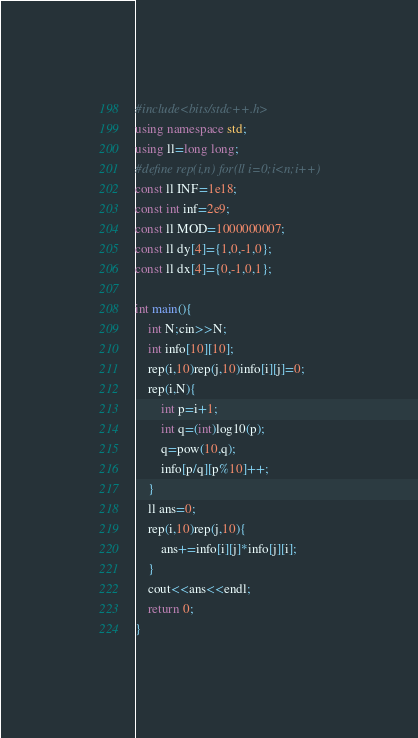<code> <loc_0><loc_0><loc_500><loc_500><_C++_>#include<bits/stdc++.h>
using namespace std;
using ll=long long;
#define rep(i,n) for(ll i=0;i<n;i++)
const ll INF=1e18;
const int inf=2e9;
const ll MOD=1000000007;
const ll dy[4]={1,0,-1,0};
const ll dx[4]={0,-1,0,1};

int main(){
    int N;cin>>N;
    int info[10][10];
    rep(i,10)rep(j,10)info[i][j]=0;
    rep(i,N){
        int p=i+1;
        int q=(int)log10(p);
        q=pow(10,q);
        info[p/q][p%10]++;
    }
    ll ans=0;
    rep(i,10)rep(j,10){
        ans+=info[i][j]*info[j][i];
    }
    cout<<ans<<endl;
    return 0;
}</code> 